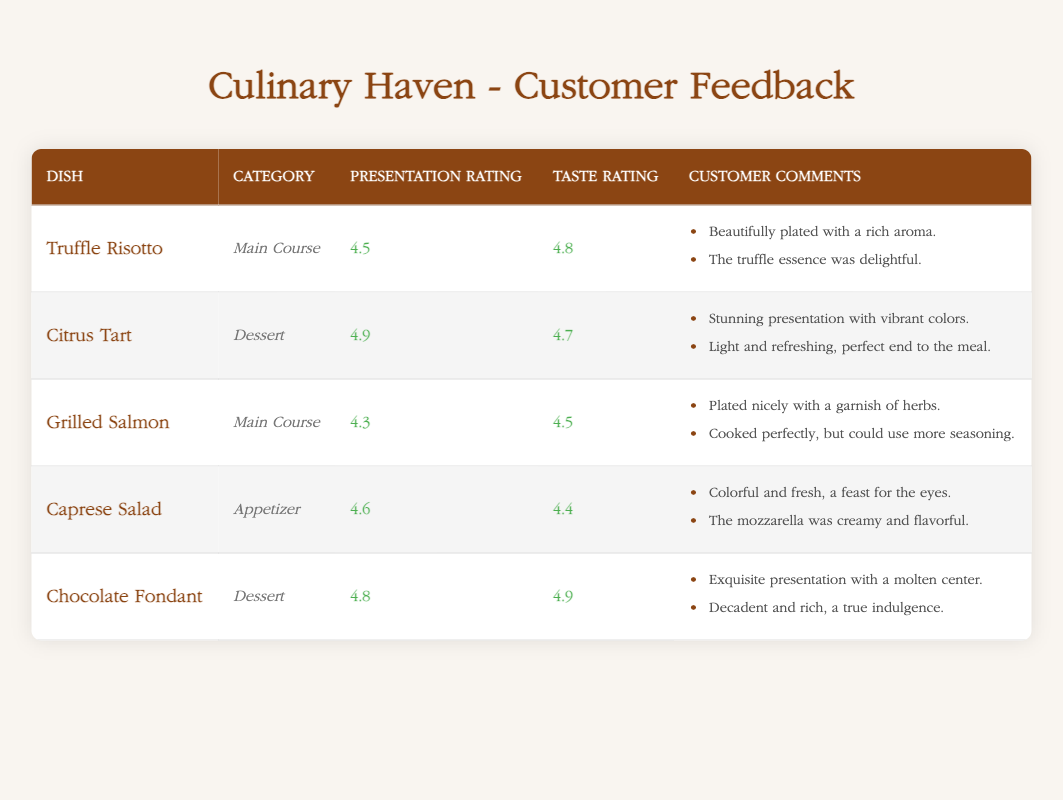What is the highest presentation rating among the dishes? The presentation ratings for the dishes are as follows: Truffle Risotto (4.5), Citrus Tart (4.9), Grilled Salmon (4.3), Caprese Salad (4.6), and Chocolate Fondant (4.8). The highest rating is 4.9 for the Citrus Tart.
Answer: 4.9 Which dish has the lowest taste rating? The taste ratings are: Truffle Risotto (4.8), Citrus Tart (4.7), Grilled Salmon (4.5), Caprese Salad (4.4), and Chocolate Fondant (4.9). The lowest rating is 4.4 for the Caprese Salad.
Answer: 4.4 Did the Grilled Salmon receive a better presentation rating than the Caprese Salad? The presentation ratings are Grilled Salmon (4.3) and Caprese Salad (4.6). Since 4.3 is less than 4.6, the Grilled Salmon did not receive a better presentation rating.
Answer: No What is the average presentation rating of all the dishes? To find the average, add the presentation ratings: 4.5 + 4.9 + 4.3 + 4.6 + 4.8 = 23.1. There are 5 dishes, so the average presentation rating is 23.1/5 = 4.62.
Answer: 4.62 How many dishes received a presentation rating of 4.5 or higher? The presentation ratings of the dishes are: Truffle Risotto (4.5), Citrus Tart (4.9), Grilled Salmon (4.3), Caprese Salad (4.6), and Chocolate Fondant (4.8). The dishes that received 4.5 or higher are Truffle Risotto, Citrus Tart, Caprese Salad, and Chocolate Fondant. This makes a total of 4 dishes.
Answer: 4 